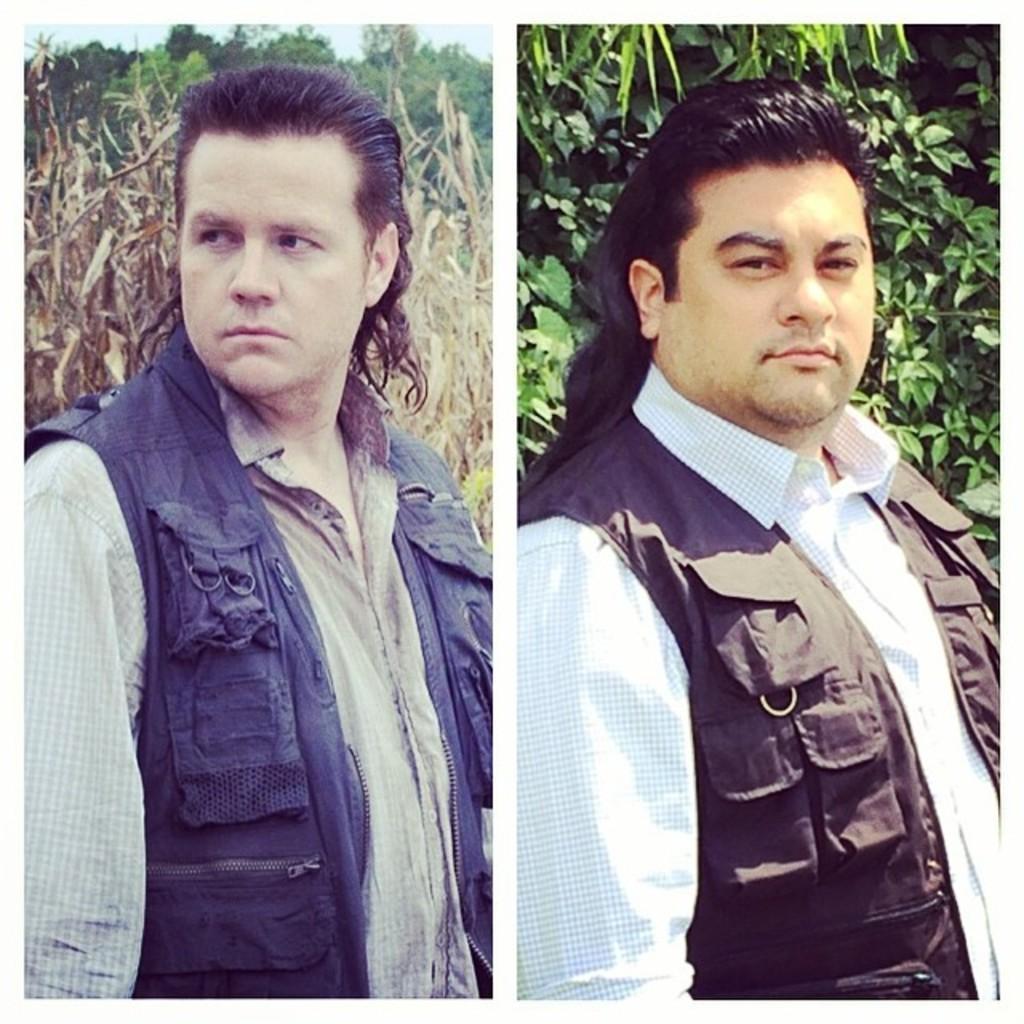In one or two sentences, can you explain what this image depicts? This image is a collage of two images. They both are same images. In this image a man is standing and in the background there are a few trees and plants. 